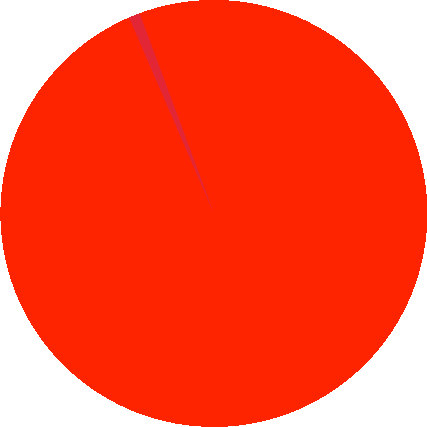Convert chart. <chart><loc_0><loc_0><loc_500><loc_500><pie_chart><fcel>Trade receivables - third<fcel>Allowance for doubtful<nl><fcel>99.16%<fcel>0.84%<nl></chart> 